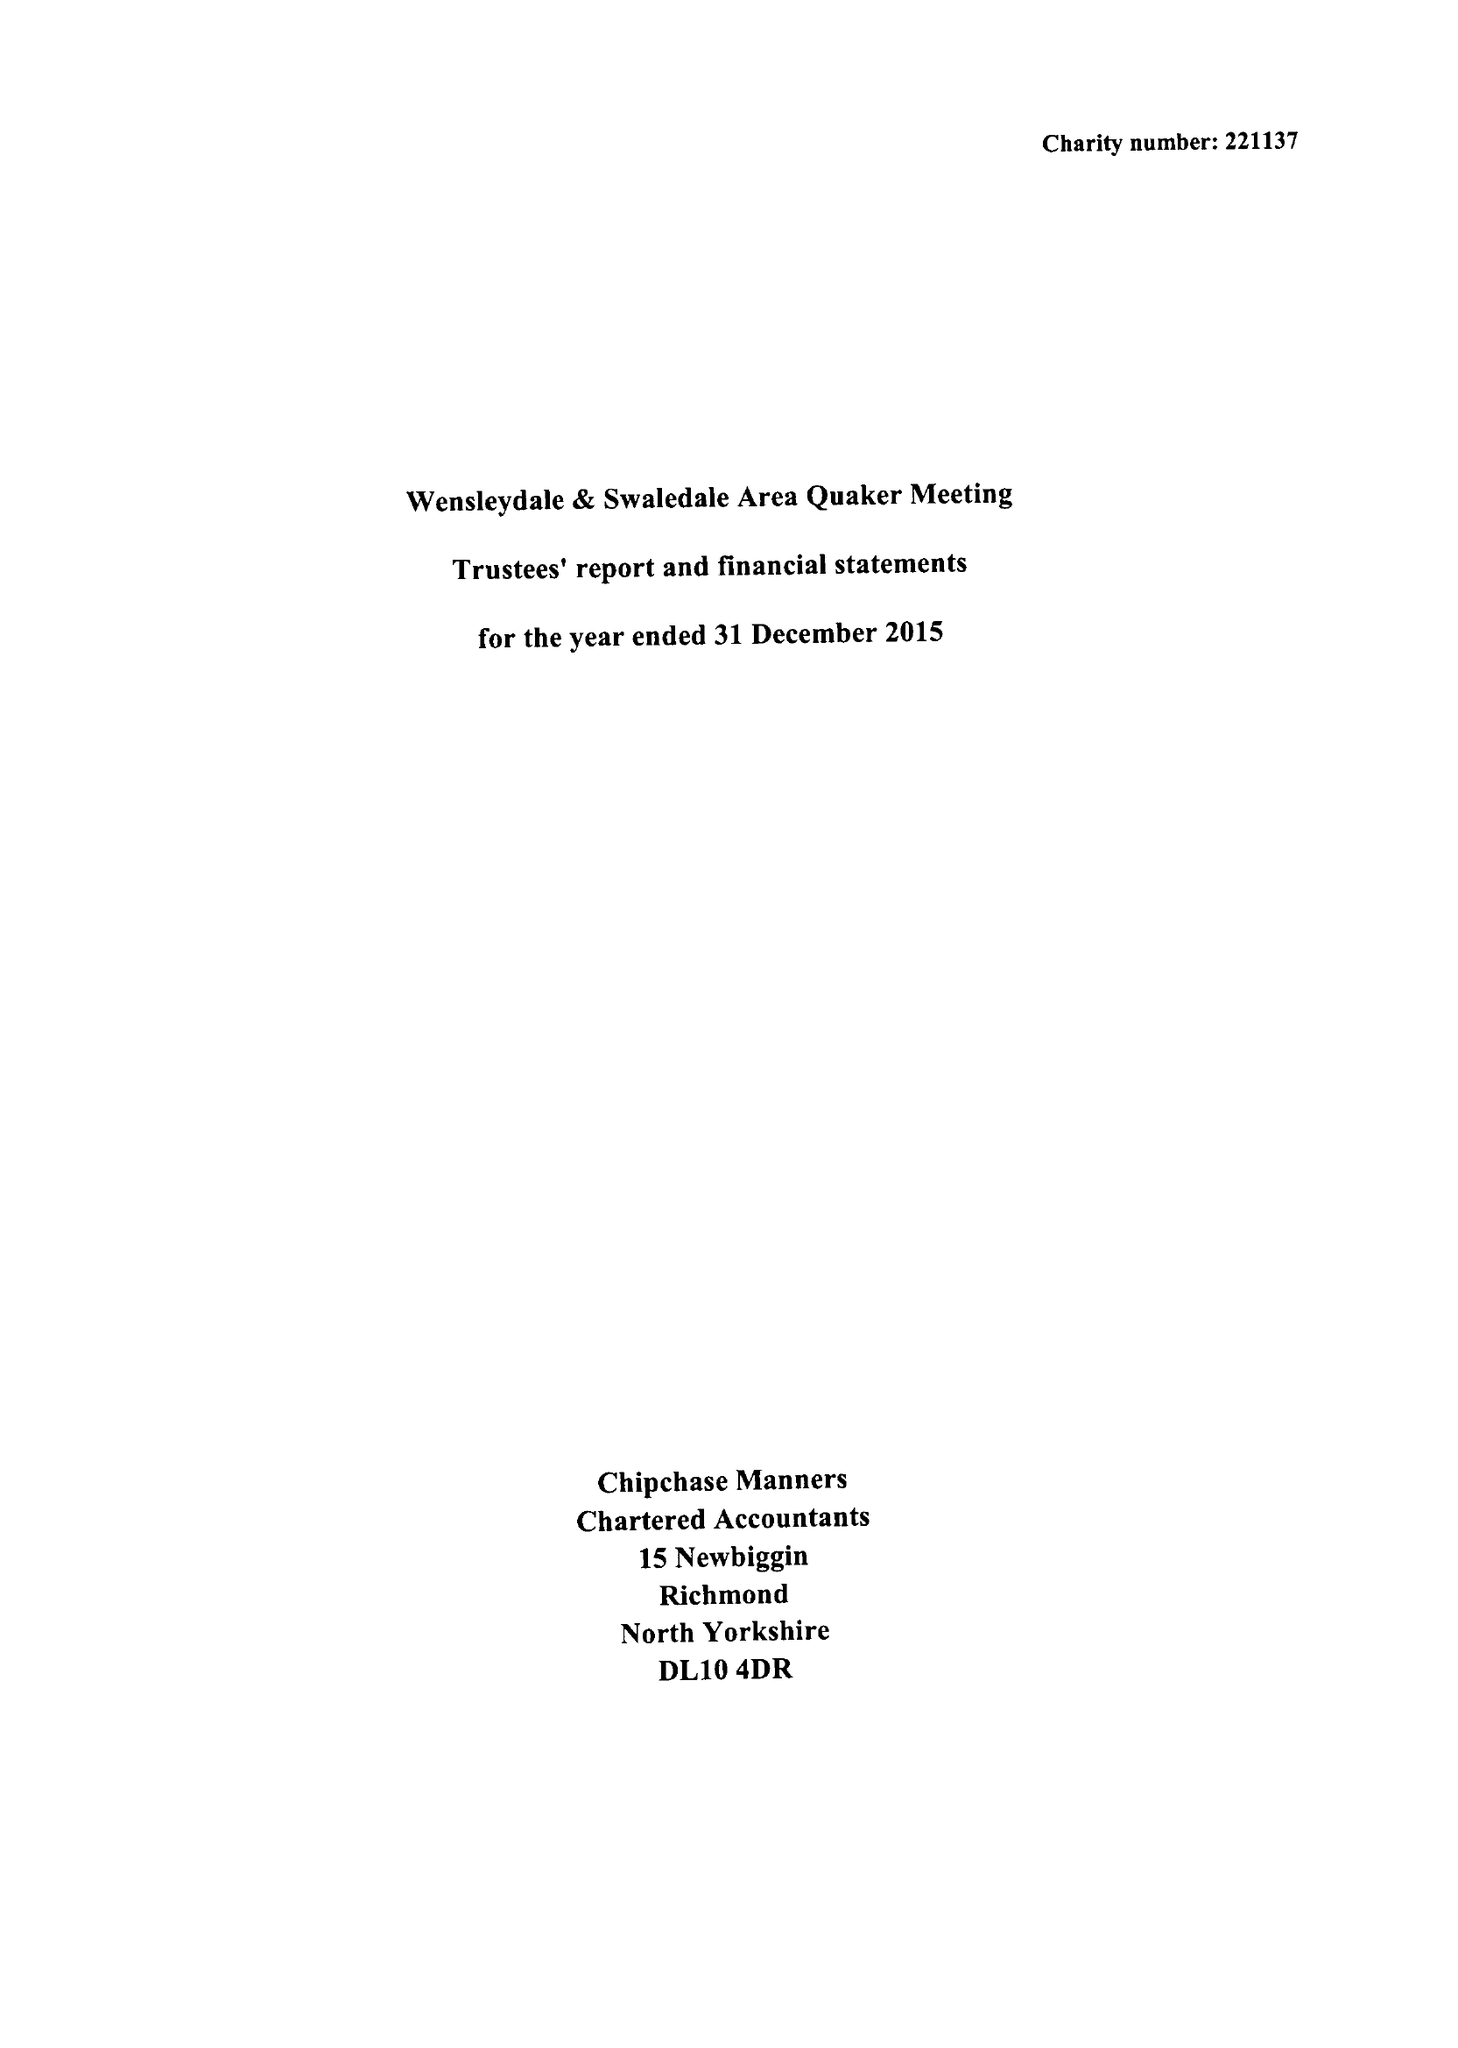What is the value for the charity_name?
Answer the question using a single word or phrase. Wensleydale and Swaledale Quaker Trust 